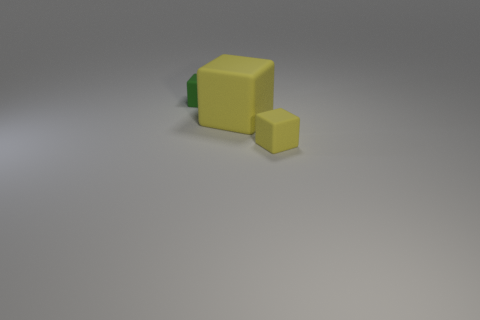What number of big things are yellow matte blocks or cyan cylinders?
Make the answer very short. 1. What number of green rubber objects are behind the tiny matte block that is behind the tiny yellow matte block?
Your answer should be compact. 0. Is there a small green rubber thing of the same shape as the tiny yellow matte thing?
Give a very brief answer. Yes. Is the shape of the yellow thing to the right of the big matte object the same as the large yellow rubber thing in front of the tiny green cube?
Give a very brief answer. Yes. The rubber object that is in front of the green cube and to the left of the tiny yellow rubber object has what shape?
Offer a terse response. Cube. Is there another matte object that has the same size as the green object?
Make the answer very short. Yes. There is a big rubber cube; is its color the same as the small rubber cube that is on the right side of the tiny green rubber block?
Keep it short and to the point. Yes. What is the large yellow block made of?
Make the answer very short. Rubber. The tiny matte object that is right of the small green block is what color?
Your answer should be very brief. Yellow. What number of small matte things have the same color as the big cube?
Your answer should be very brief. 1. 